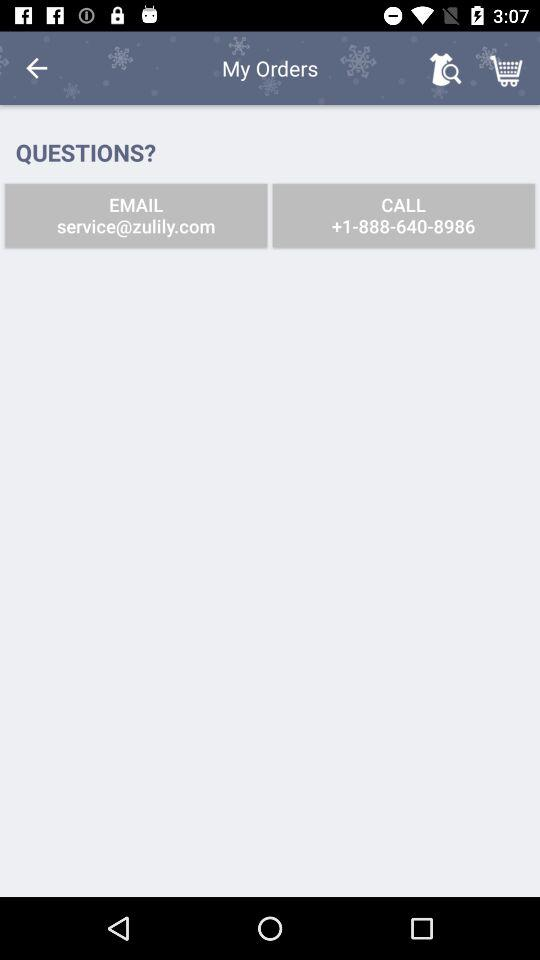What is the contact number? The contact number is +1-888-640-8986. 